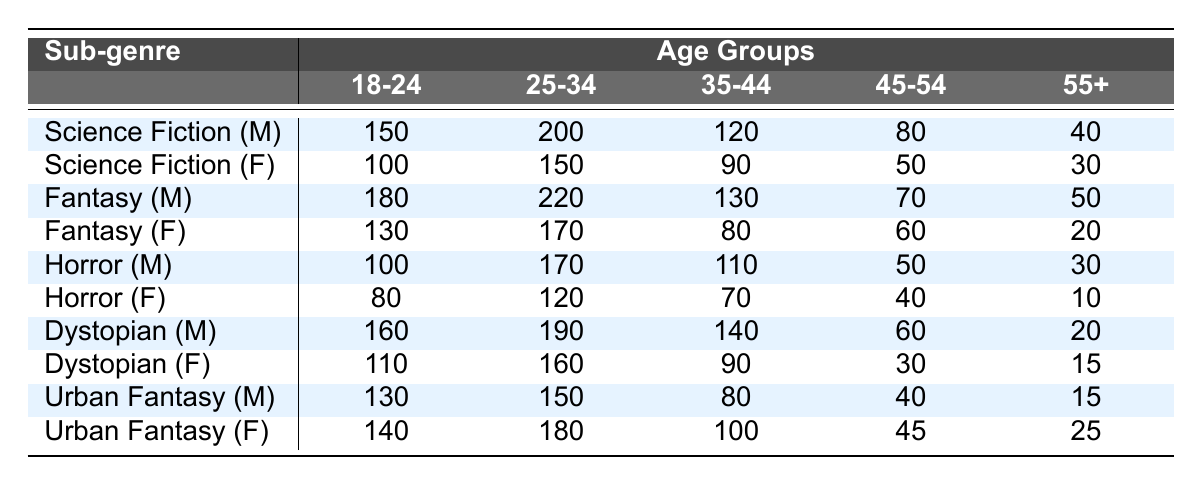What is the number of male readers aged 25-34 for the Fantasy sub-genre? Referring to the row for Fantasy (M), the number in the 25-34 age column is 220.
Answer: 220 What is the total number of female readers aged 18-24 across all sub-genres? To find this total, we sum the values from the Female rows for the 18-24 age group: 100 (Sci-Fi) + 130 (Fantasy) + 80 (Horror) + 110 (Dystopian) + 140 (Urban Fantasy) = 660.
Answer: 660 Is the number of male readers aged 55+ in Urban Fantasy greater than in Horror? In the Urban Fantasy (M) row, the number is 15, and in the Horror (M) row, the number is 30. Since 15 is not greater than 30, the answer is no.
Answer: No Which sub-genre has the highest number of female readers aged 35-44? Looking at the Female rows, we identify the values for the 35-44 age group: 90 (Sci-Fi), 80 (Fantasy), 70 (Horror), 90 (Dystopian), and 100 (Urban Fantasy). The highest value is 100 from Urban Fantasy.
Answer: Urban Fantasy What is the average number of male readers for the 45-54 age group across all sub-genres? For the 45-54 age group, we look at the Male values: 80 (Sci-Fi), 70 (Fantasy), 50 (Horror), 60 (Dystopian), and 40 (Urban Fantasy). The average is calculated as (80 + 70 + 50 + 60 + 40) / 5 = 60.
Answer: 60 